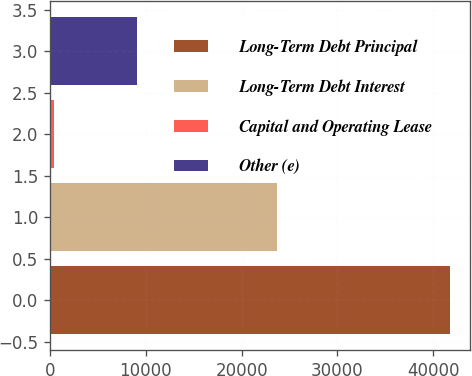<chart> <loc_0><loc_0><loc_500><loc_500><bar_chart><fcel>Long-Term Debt Principal<fcel>Long-Term Debt Interest<fcel>Capital and Operating Lease<fcel>Other (e)<nl><fcel>41752<fcel>23672<fcel>410<fcel>9136<nl></chart> 